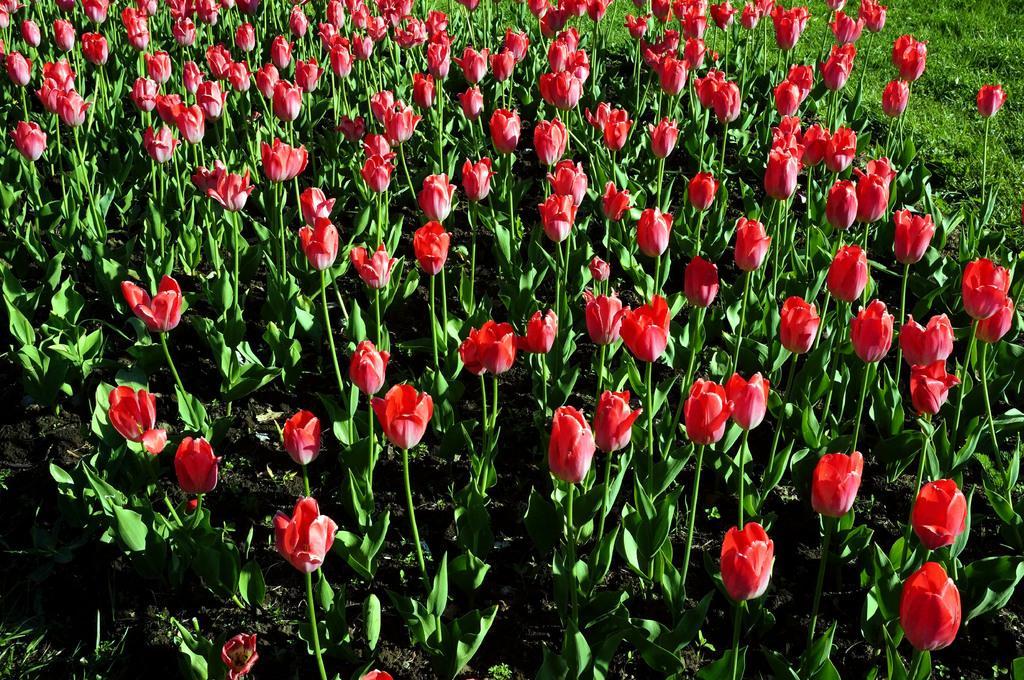Can you describe this image briefly? In this image we can see a group of plants with flowers and some grass. 